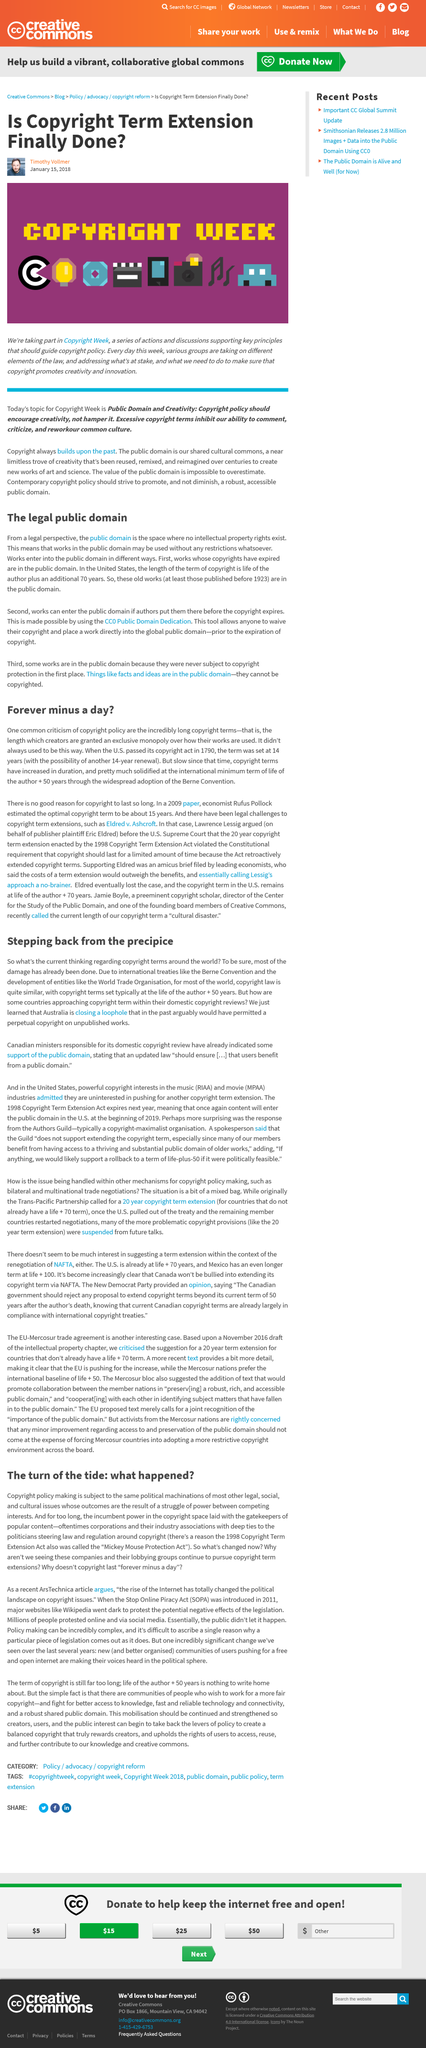Point out several critical features in this image. The Berne Convention is an international treaty that provides a standard set of rights and protections for authors of creative works, such as books, music, and art. Yes, copyright policy making is subject to the same political machination as most other legal issues. Before an author's death, their work can enter the public domain if they dedicate it with a CC0 Public Domain Dedication. The copyright for a work normally expires 50 years after the death of the author. Works enter the public domain in two ways: either their copyright expires or the author explicitly places them there before the copyright expires. 